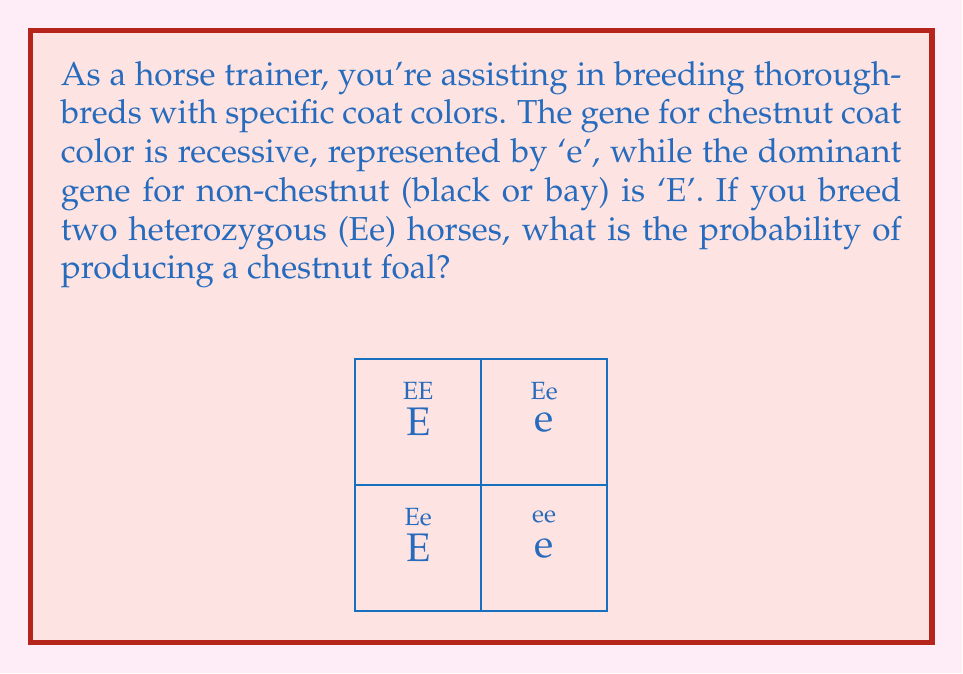Solve this math problem. Let's approach this step-by-step:

1) First, we need to understand the genetic makeup:
   - 'E' is dominant (non-chestnut)
   - 'e' is recessive (chestnut)
   - Both parent horses are heterozygous (Ee)

2) To visualize the possible outcomes, we use a Punnett square (as shown in the diagram).

3) The Punnett square shows four possible outcomes:
   - EE (non-chestnut)
   - Ee (non-chestnut)
   - Ee (non-chestnut)
   - ee (chestnut)

4) To calculate the probability, we need to determine:
   $P(\text{chestnut}) = \frac{\text{favorable outcomes}}{\text{total outcomes}}$

5) From the Punnett square:
   - There is 1 favorable outcome (ee)
   - There are 4 total outcomes

6) Therefore, the probability is:
   $P(\text{chestnut}) = \frac{1}{4} = 0.25 = 25\%$

This means there is a 25% chance of producing a chestnut foal from this breeding pair.
Answer: $\frac{1}{4}$ or $25\%$ 